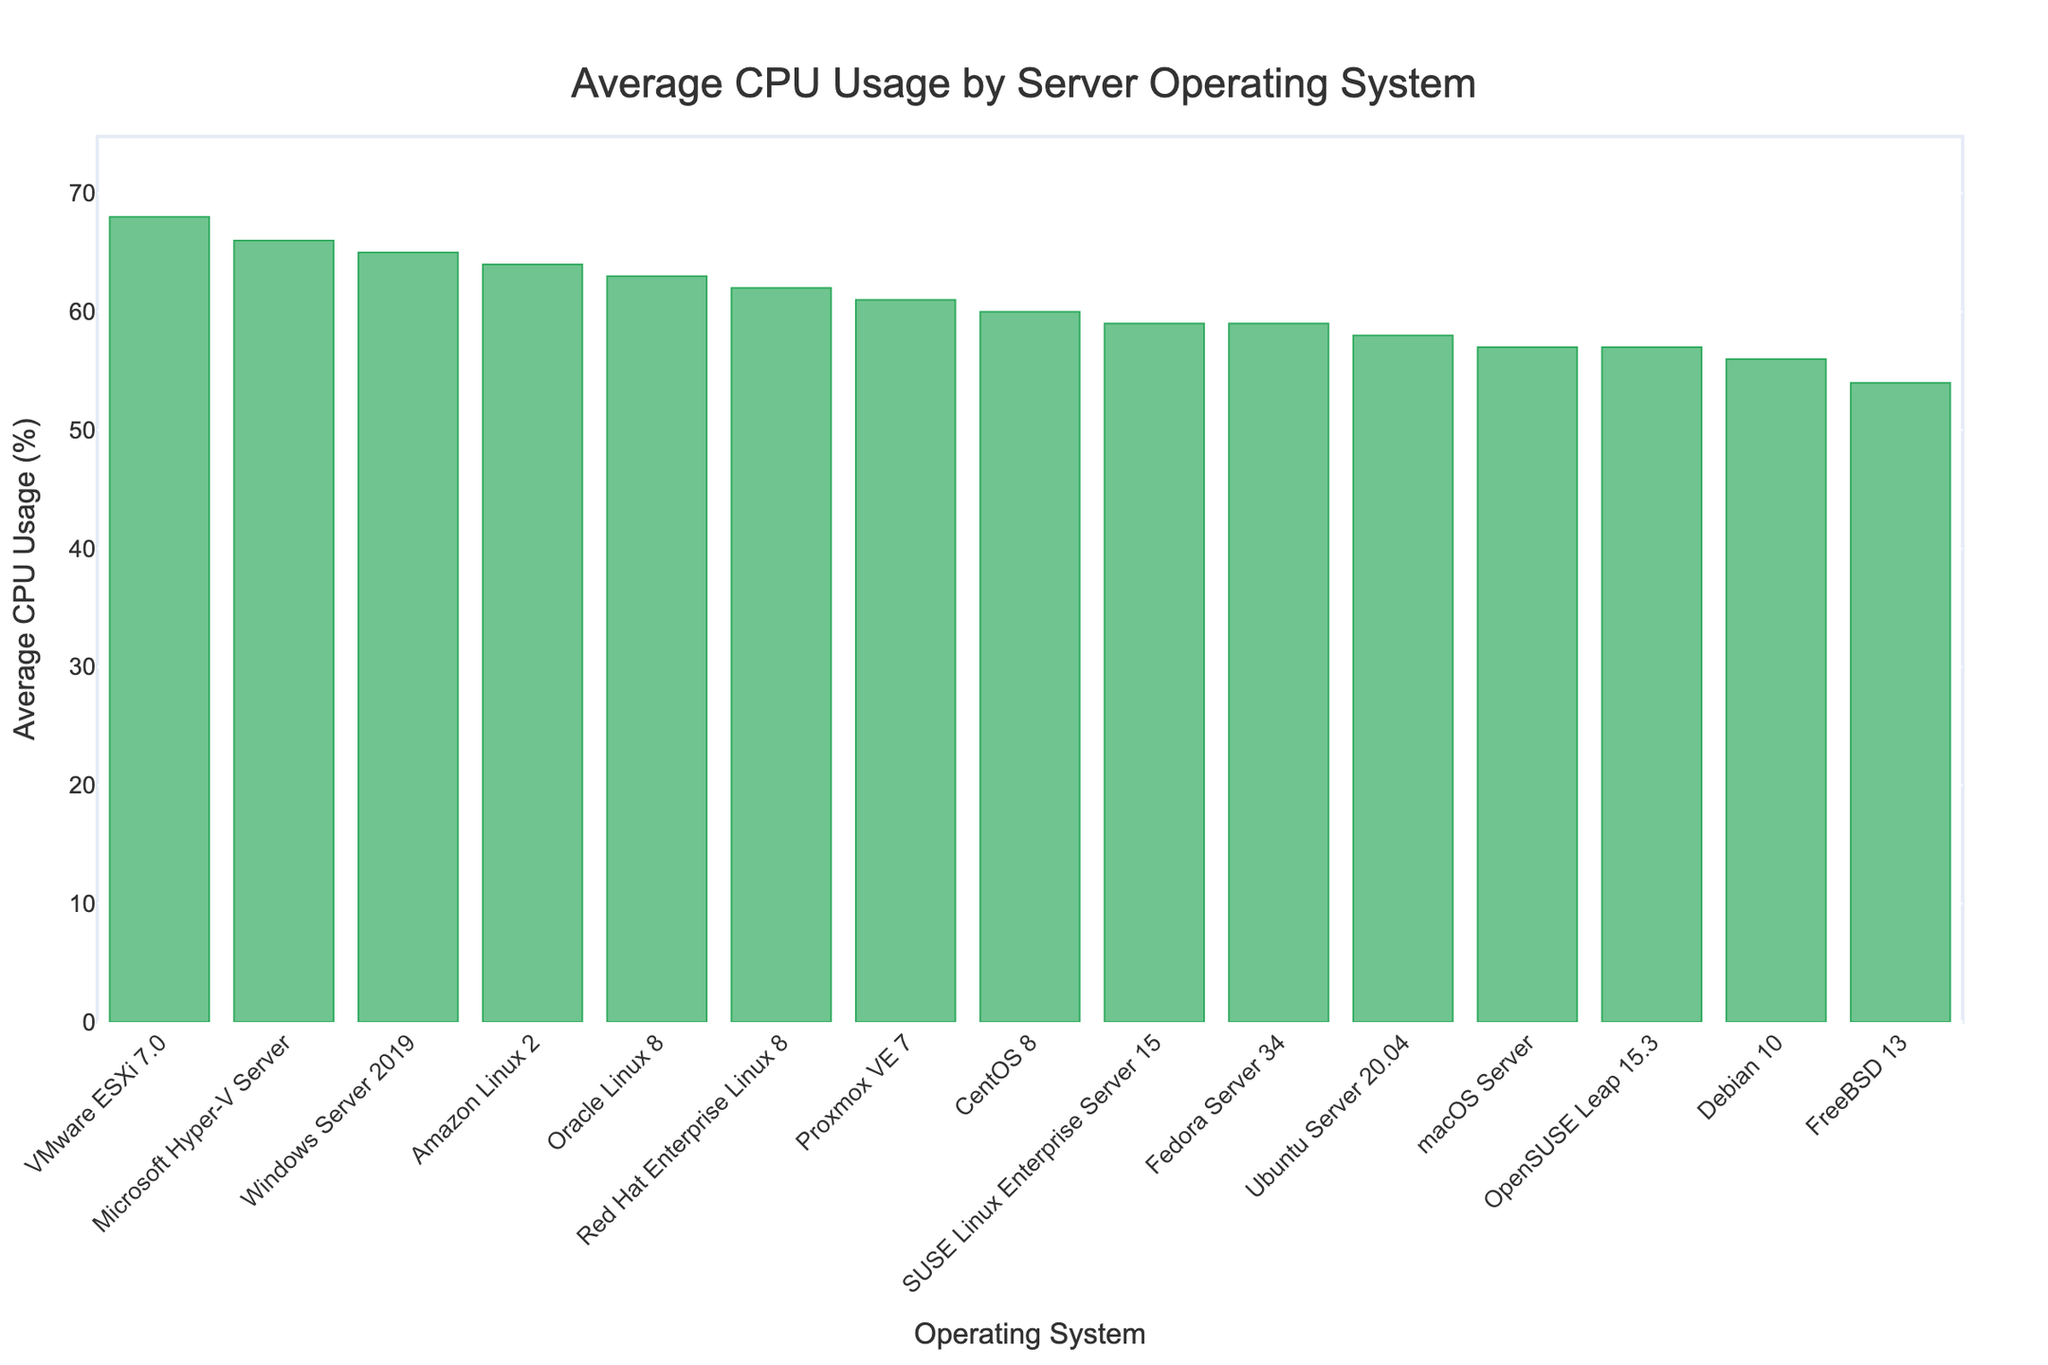Which operating system has the highest average CPU usage? The bar representing VMware ESXi 7.0 is the tallest in the chart, indicating it has the highest average CPU usage.
Answer: VMware ESXi 7.0 Which two operating systems have the closest average CPU usage values? By visually comparing the bars, Amazon Linux 2 (64%) and Oracle Linux 8 (63%) are very close in height, indicating similar CPU usage percentages.
Answer: Amazon Linux 2 and Oracle Linux 8 What is the difference in average CPU usage between Windows Server 2019 and Ubuntu Server 20.04? The average CPU usage for Windows Server 2019 is 65%, and for Ubuntu Server 20.04 is 58%. Calculating the difference: 65 - 58.
Answer: 7% What are the top three operating systems with the highest average CPU usage? Identifying the three tallest bars reveals they are Microsoft Hyper-V Server (66%), VMware ESXi 7.0 (68%), and Windows Server 2019 (65%).
Answer: VMware ESXi 7.0, Microsoft Hyper-V Server, Windows Server 2019 Which operating system has the lowest average CPU usage? The bar representing FreeBSD 13 is the shortest in the chart, indicating it has the lowest average CPU usage.
Answer: FreeBSD 13 What is the average CPU usage of the operating systems with the three lowest values? The lowest CPU usage values are FreeBSD 13 (54%), Debian 10 (56%), and OpenSUSE Leap 15.3 (57%). Calculating the average: (54 + 56 + 57) / 3.
Answer: 55.67% How much higher is the CPU usage of Proxmox VE 7 compared to Fedora Server 34? Proxmox VE 7 has a CPU usage of 61% and Fedora Server 34 has 59%. Calculating the difference: 61 - 59.
Answer: 2% Which operating system has slightly higher average CPU usage: SUSE Linux Enterprise Server 15 or CentOS 8? Comparing the heights of the bars, CentOS 8 (60%) slightly exceeds SUSE Linux Enterprise Server 15 (59%).
Answer: CentOS 8 Are there more Windows or Linux operating systems in the top five for CPU usage? The top five are VMware ESXi 7.0 (68%), Microsoft Hyper-V Server (66%), Windows Server 2019 (65%), Amazon Linux 2 (64%), and Oracle Linux 8 (63%). There are 2 Windows systems and 3 Linux systems.
Answer: Linux What is the combined average CPU usage of macOS Server and OpenSUSE Leap 15.3? macOS Server has an average CPU usage of 57% and OpenSUSE Leap 15.3 also has 57%. Summing these values: 57 + 57
Answer: 114% 